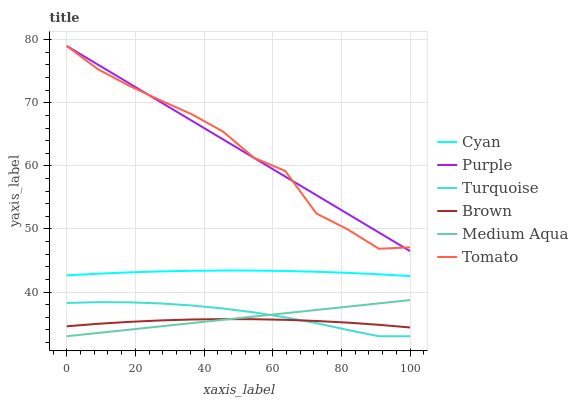Does Brown have the minimum area under the curve?
Answer yes or no. Yes. Does Purple have the maximum area under the curve?
Answer yes or no. Yes. Does Turquoise have the minimum area under the curve?
Answer yes or no. No. Does Turquoise have the maximum area under the curve?
Answer yes or no. No. Is Purple the smoothest?
Answer yes or no. Yes. Is Tomato the roughest?
Answer yes or no. Yes. Is Brown the smoothest?
Answer yes or no. No. Is Brown the roughest?
Answer yes or no. No. Does Brown have the lowest value?
Answer yes or no. No. Does Purple have the highest value?
Answer yes or no. Yes. Does Turquoise have the highest value?
Answer yes or no. No. Is Brown less than Tomato?
Answer yes or no. Yes. Is Cyan greater than Brown?
Answer yes or no. Yes. Does Brown intersect Tomato?
Answer yes or no. No. 